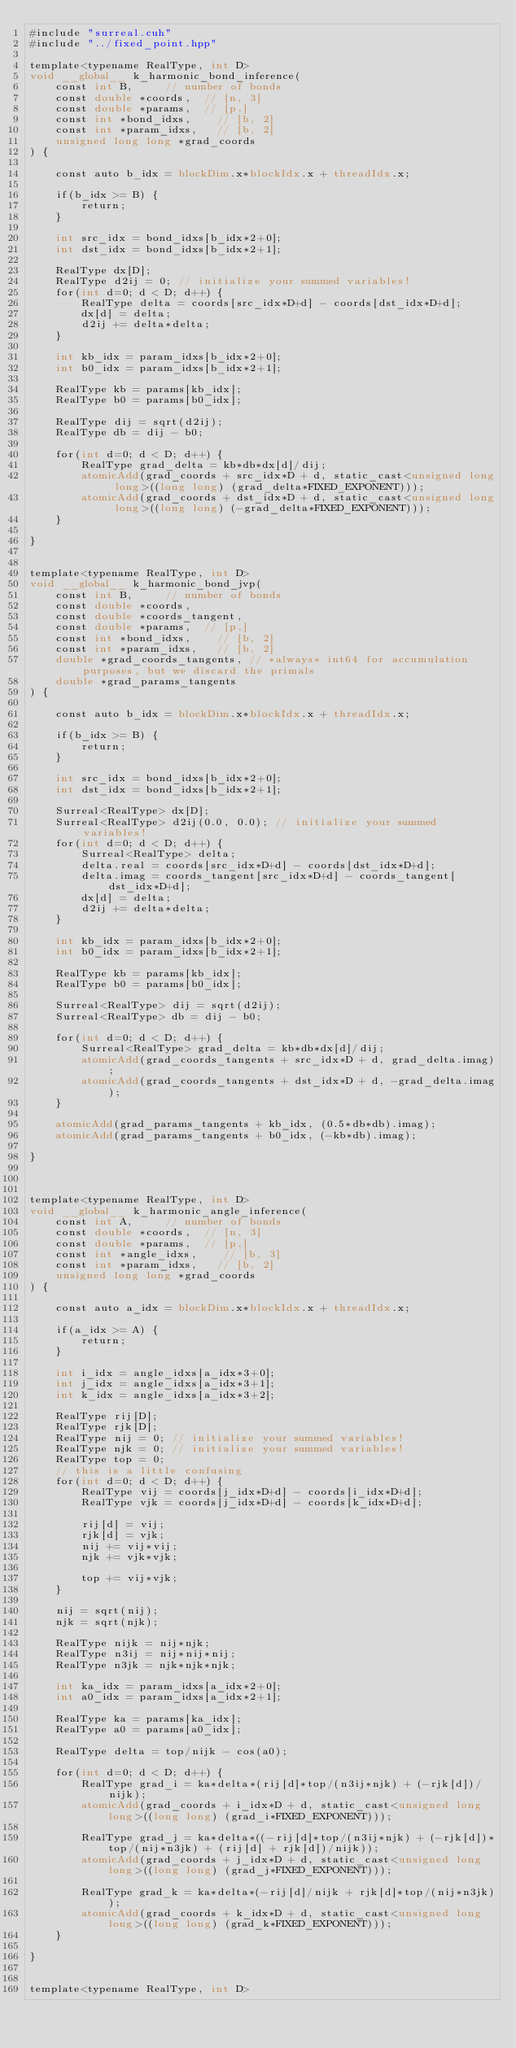Convert code to text. <code><loc_0><loc_0><loc_500><loc_500><_Cuda_>#include "surreal.cuh"
#include "../fixed_point.hpp"

template<typename RealType, int D>
void __global__ k_harmonic_bond_inference(
    const int B,     // number of bonds
    const double *coords,  // [n, 3]
    const double *params,  // [p,]
    const int *bond_idxs,    // [b, 2]
    const int *param_idxs,   // [b, 2]
    unsigned long long *grad_coords
) {

    const auto b_idx = blockDim.x*blockIdx.x + threadIdx.x;

    if(b_idx >= B) {
        return;
    }

    int src_idx = bond_idxs[b_idx*2+0];
    int dst_idx = bond_idxs[b_idx*2+1];

    RealType dx[D];
    RealType d2ij = 0; // initialize your summed variables!
    for(int d=0; d < D; d++) {
        RealType delta = coords[src_idx*D+d] - coords[dst_idx*D+d];
        dx[d] = delta;
        d2ij += delta*delta;
    }

    int kb_idx = param_idxs[b_idx*2+0];
    int b0_idx = param_idxs[b_idx*2+1];

    RealType kb = params[kb_idx];
    RealType b0 = params[b0_idx];

    RealType dij = sqrt(d2ij);
    RealType db = dij - b0;

    for(int d=0; d < D; d++) {
        RealType grad_delta = kb*db*dx[d]/dij;
        atomicAdd(grad_coords + src_idx*D + d, static_cast<unsigned long long>((long long) (grad_delta*FIXED_EXPONENT)));
        atomicAdd(grad_coords + dst_idx*D + d, static_cast<unsigned long long>((long long) (-grad_delta*FIXED_EXPONENT)));
    }

}


template<typename RealType, int D>
void __global__ k_harmonic_bond_jvp(
    const int B,     // number of bonds
    const double *coords,  
    const double *coords_tangent,  
    const double *params,  // [p,]
    const int *bond_idxs,    // [b, 2]
    const int *param_idxs,   // [b, 2]
    double *grad_coords_tangents, // *always* int64 for accumulation purposes, but we discard the primals
    double *grad_params_tangents
) {

    const auto b_idx = blockDim.x*blockIdx.x + threadIdx.x;

    if(b_idx >= B) {
        return;
    }

    int src_idx = bond_idxs[b_idx*2+0];
    int dst_idx = bond_idxs[b_idx*2+1];

    Surreal<RealType> dx[D];
    Surreal<RealType> d2ij(0.0, 0.0); // initialize your summed variables!
    for(int d=0; d < D; d++) {
        Surreal<RealType> delta;
        delta.real = coords[src_idx*D+d] - coords[dst_idx*D+d];
        delta.imag = coords_tangent[src_idx*D+d] - coords_tangent[dst_idx*D+d];
        dx[d] = delta;
        d2ij += delta*delta;
    }

    int kb_idx = param_idxs[b_idx*2+0];
    int b0_idx = param_idxs[b_idx*2+1];

    RealType kb = params[kb_idx];
    RealType b0 = params[b0_idx];

    Surreal<RealType> dij = sqrt(d2ij);
    Surreal<RealType> db = dij - b0;

    for(int d=0; d < D; d++) {
        Surreal<RealType> grad_delta = kb*db*dx[d]/dij;
        atomicAdd(grad_coords_tangents + src_idx*D + d, grad_delta.imag);
        atomicAdd(grad_coords_tangents + dst_idx*D + d, -grad_delta.imag);
    }

    atomicAdd(grad_params_tangents + kb_idx, (0.5*db*db).imag);
    atomicAdd(grad_params_tangents + b0_idx, (-kb*db).imag);

}



template<typename RealType, int D>
void __global__ k_harmonic_angle_inference(
    const int A,     // number of bonds
    const double *coords,  // [n, 3]
    const double *params,  // [p,]
    const int *angle_idxs,    // [b, 3]
    const int *param_idxs,   // [b, 2]
    unsigned long long *grad_coords
) {

    const auto a_idx = blockDim.x*blockIdx.x + threadIdx.x;

    if(a_idx >= A) {
        return;
    }

    int i_idx = angle_idxs[a_idx*3+0];
    int j_idx = angle_idxs[a_idx*3+1];
    int k_idx = angle_idxs[a_idx*3+2];

    RealType rij[D];
    RealType rjk[D];
    RealType nij = 0; // initialize your summed variables!
    RealType njk = 0; // initialize your summed variables!
    RealType top = 0;
    // this is a little confusing
    for(int d=0; d < D; d++) {
        RealType vij = coords[j_idx*D+d] - coords[i_idx*D+d];
        RealType vjk = coords[j_idx*D+d] - coords[k_idx*D+d];

        rij[d] = vij;
        rjk[d] = vjk;
        nij += vij*vij;
        njk += vjk*vjk;

        top += vij*vjk;
    }

    nij = sqrt(nij);
    njk = sqrt(njk);

    RealType nijk = nij*njk;
    RealType n3ij = nij*nij*nij;
    RealType n3jk = njk*njk*njk;

    int ka_idx = param_idxs[a_idx*2+0];
    int a0_idx = param_idxs[a_idx*2+1];

    RealType ka = params[ka_idx];
    RealType a0 = params[a0_idx];

    RealType delta = top/nijk - cos(a0);

    for(int d=0; d < D; d++) {
        RealType grad_i = ka*delta*(rij[d]*top/(n3ij*njk) + (-rjk[d])/nijk);
        atomicAdd(grad_coords + i_idx*D + d, static_cast<unsigned long long>((long long) (grad_i*FIXED_EXPONENT)));

        RealType grad_j = ka*delta*((-rij[d]*top/(n3ij*njk) + (-rjk[d])*top/(nij*n3jk) + (rij[d] + rjk[d])/nijk));
        atomicAdd(grad_coords + j_idx*D + d, static_cast<unsigned long long>((long long) (grad_j*FIXED_EXPONENT)));

        RealType grad_k = ka*delta*(-rij[d]/nijk + rjk[d]*top/(nij*n3jk));
        atomicAdd(grad_coords + k_idx*D + d, static_cast<unsigned long long>((long long) (grad_k*FIXED_EXPONENT)));
    }

}


template<typename RealType, int D></code> 